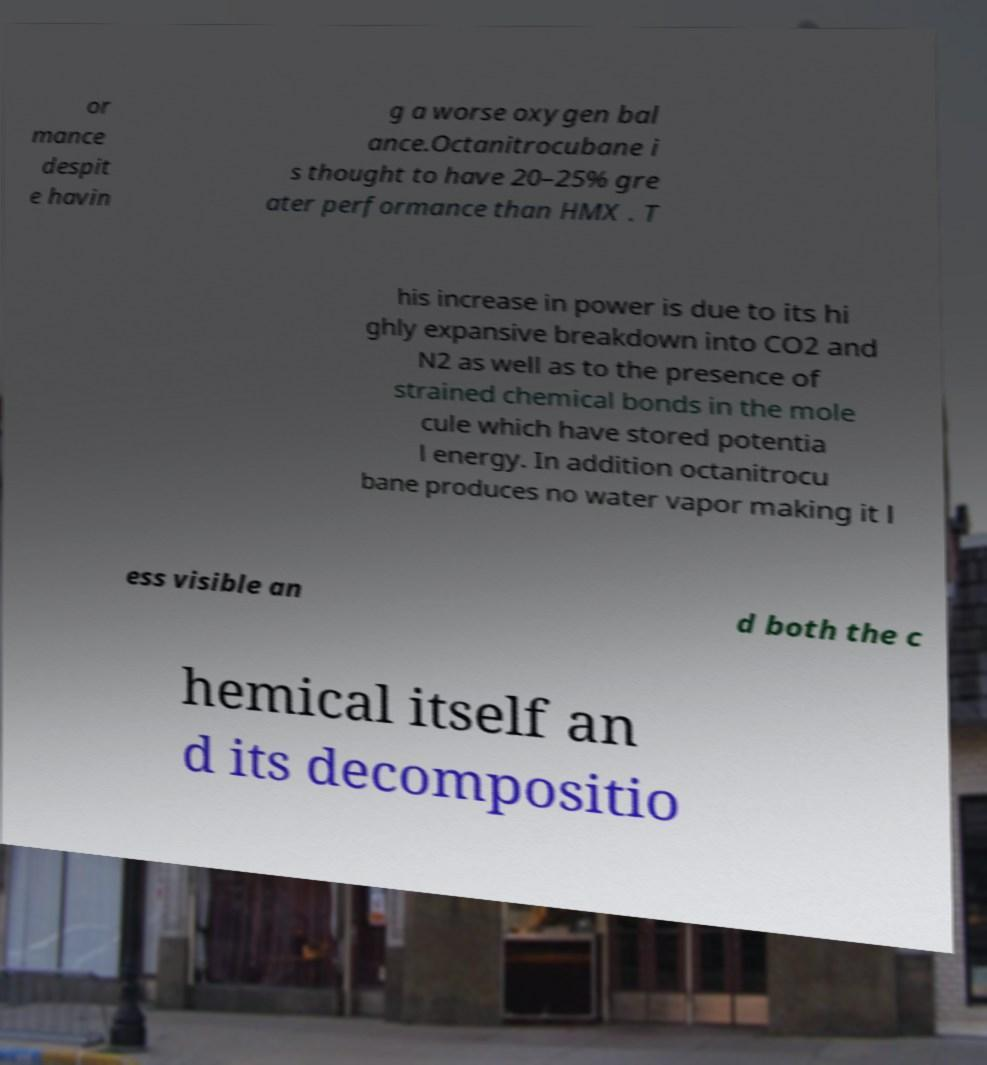Can you accurately transcribe the text from the provided image for me? or mance despit e havin g a worse oxygen bal ance.Octanitrocubane i s thought to have 20–25% gre ater performance than HMX . T his increase in power is due to its hi ghly expansive breakdown into CO2 and N2 as well as to the presence of strained chemical bonds in the mole cule which have stored potentia l energy. In addition octanitrocu bane produces no water vapor making it l ess visible an d both the c hemical itself an d its decompositio 